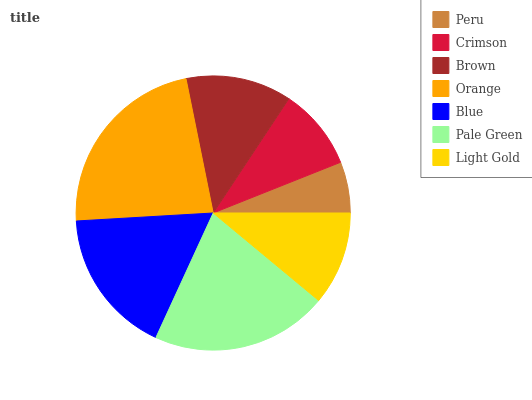Is Peru the minimum?
Answer yes or no. Yes. Is Orange the maximum?
Answer yes or no. Yes. Is Crimson the minimum?
Answer yes or no. No. Is Crimson the maximum?
Answer yes or no. No. Is Crimson greater than Peru?
Answer yes or no. Yes. Is Peru less than Crimson?
Answer yes or no. Yes. Is Peru greater than Crimson?
Answer yes or no. No. Is Crimson less than Peru?
Answer yes or no. No. Is Brown the high median?
Answer yes or no. Yes. Is Brown the low median?
Answer yes or no. Yes. Is Orange the high median?
Answer yes or no. No. Is Peru the low median?
Answer yes or no. No. 